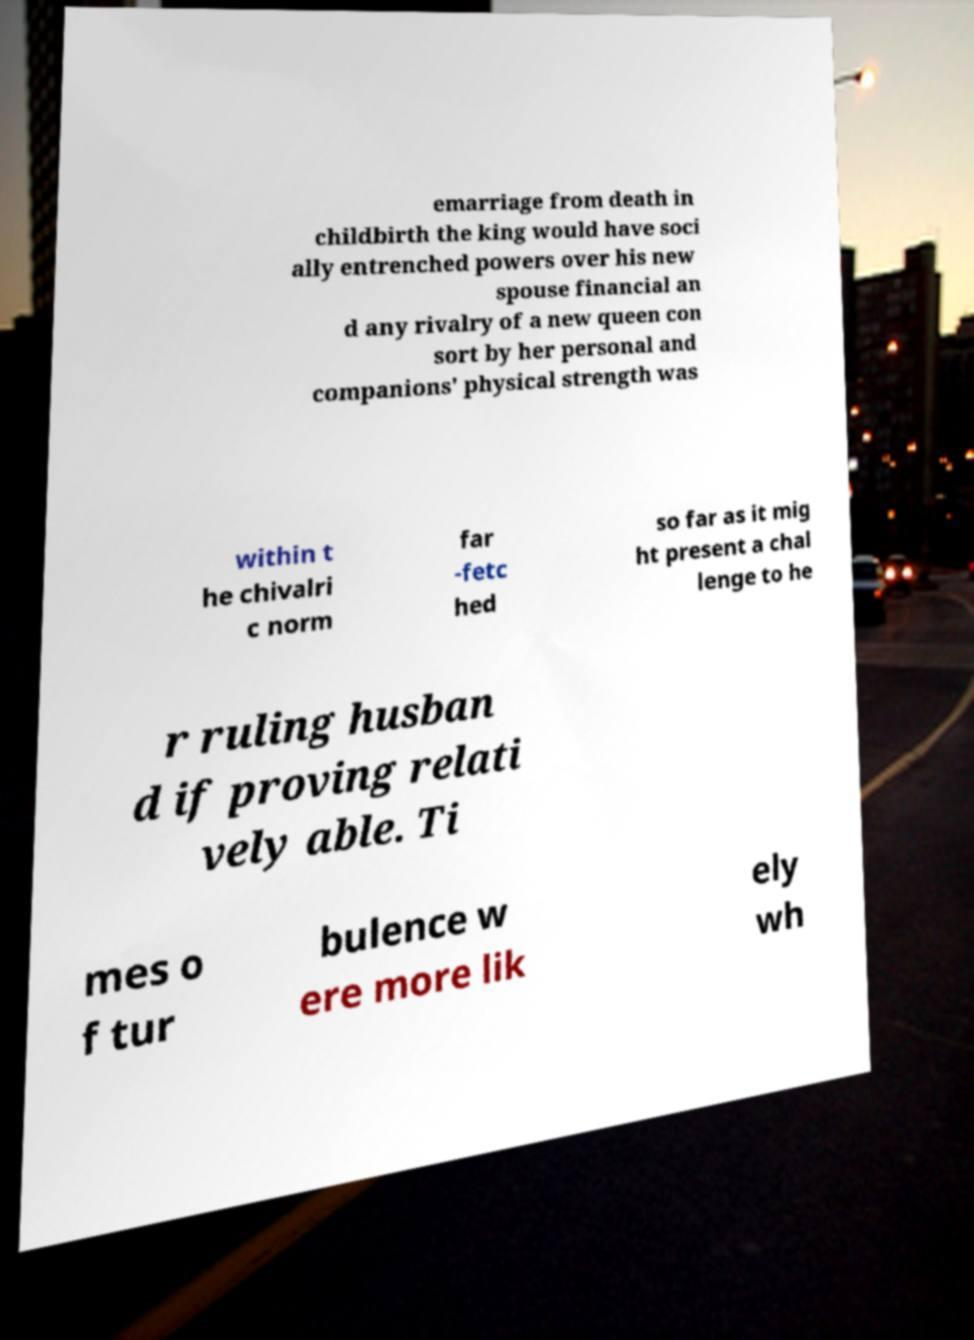Please read and relay the text visible in this image. What does it say? emarriage from death in childbirth the king would have soci ally entrenched powers over his new spouse financial an d any rivalry of a new queen con sort by her personal and companions' physical strength was within t he chivalri c norm far -fetc hed so far as it mig ht present a chal lenge to he r ruling husban d if proving relati vely able. Ti mes o f tur bulence w ere more lik ely wh 